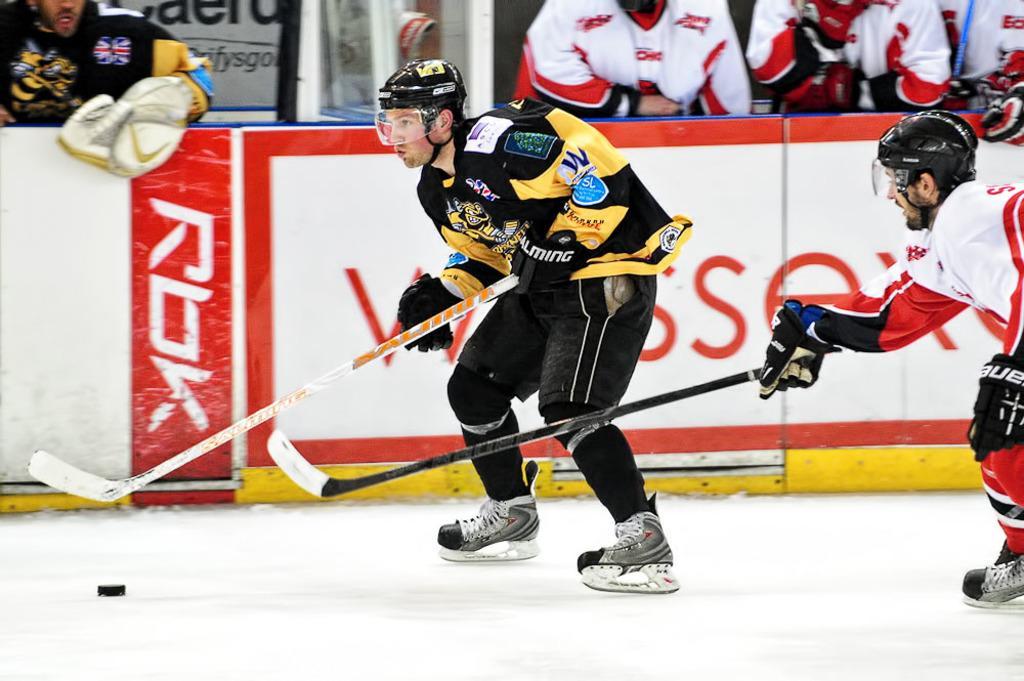Please provide a concise description of this image. In this picture we can see two men wore helmets, gloves, ice skates and holding sticks with their hands on snow and in the background we can see some people standing, posters and some objects. 